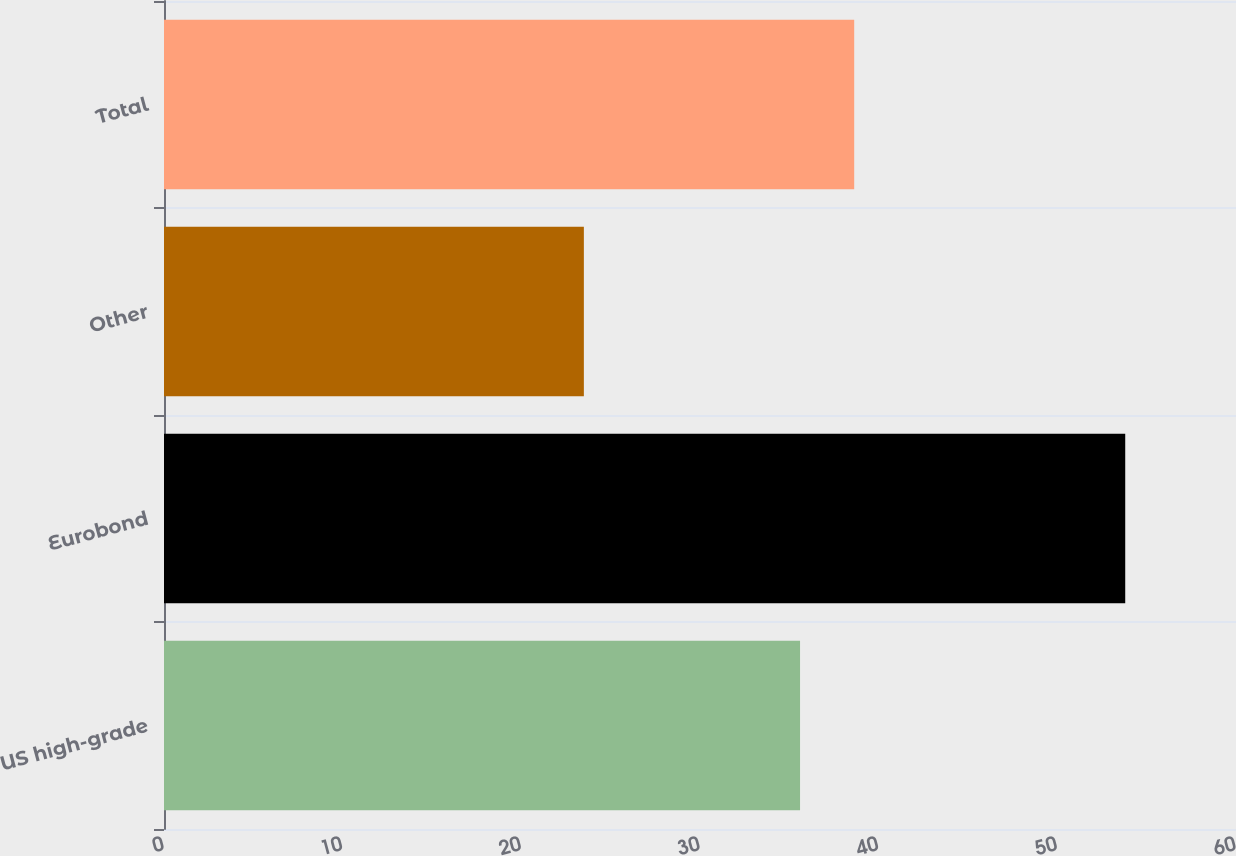<chart> <loc_0><loc_0><loc_500><loc_500><bar_chart><fcel>US high-grade<fcel>Eurobond<fcel>Other<fcel>Total<nl><fcel>35.6<fcel>53.8<fcel>23.5<fcel>38.63<nl></chart> 